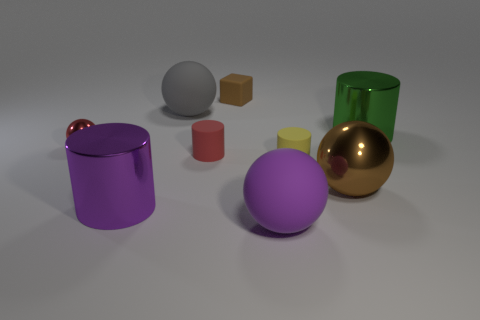Subtract 1 cylinders. How many cylinders are left? 3 Subtract all brown cylinders. Subtract all purple spheres. How many cylinders are left? 4 Add 1 brown cubes. How many objects exist? 10 Subtract all cubes. How many objects are left? 8 Subtract 1 yellow cylinders. How many objects are left? 8 Subtract all tiny brown cubes. Subtract all large yellow cylinders. How many objects are left? 8 Add 8 yellow objects. How many yellow objects are left? 9 Add 1 big blue rubber blocks. How many big blue rubber blocks exist? 1 